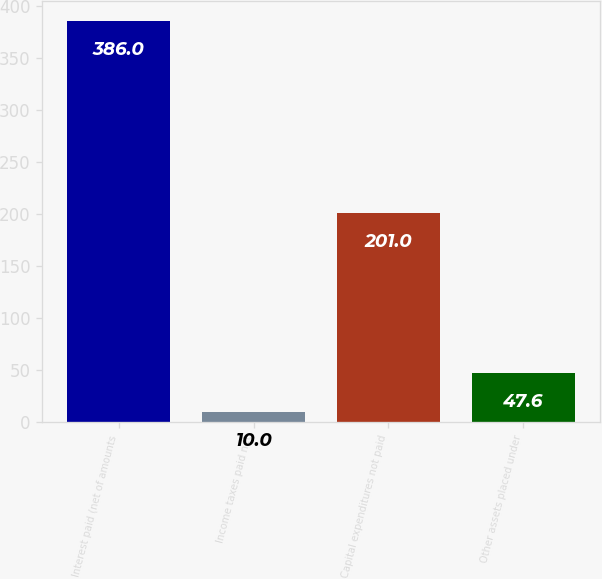Convert chart. <chart><loc_0><loc_0><loc_500><loc_500><bar_chart><fcel>Interest paid (net of amounts<fcel>Income taxes paid net<fcel>Capital expenditures not paid<fcel>Other assets placed under<nl><fcel>386<fcel>10<fcel>201<fcel>47.6<nl></chart> 